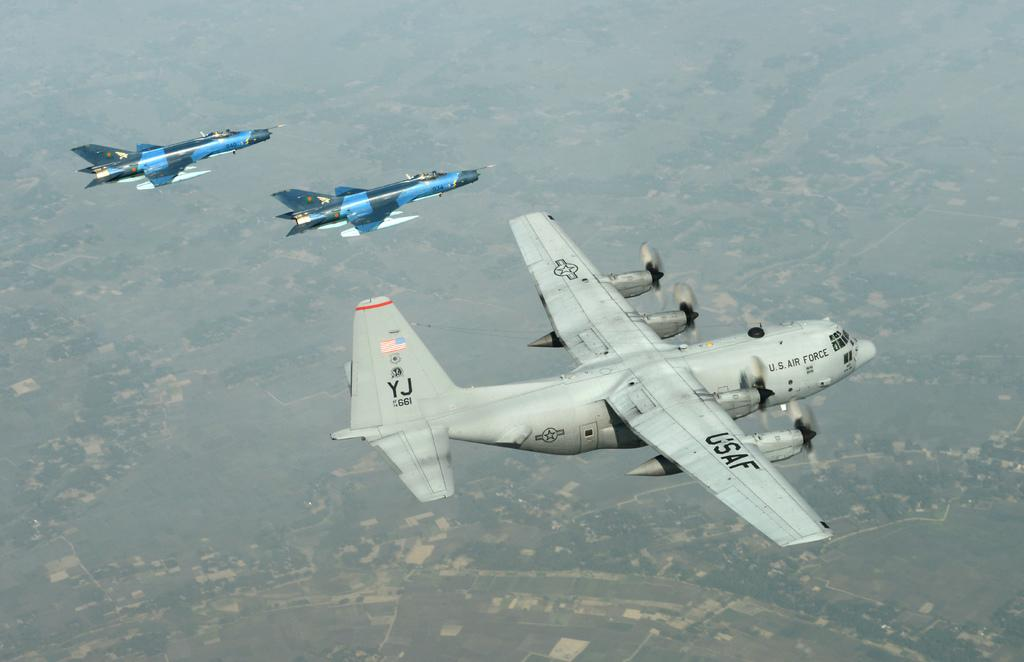<image>
Describe the image concisely. Two blue jets flying next to a gray USAF jet. 